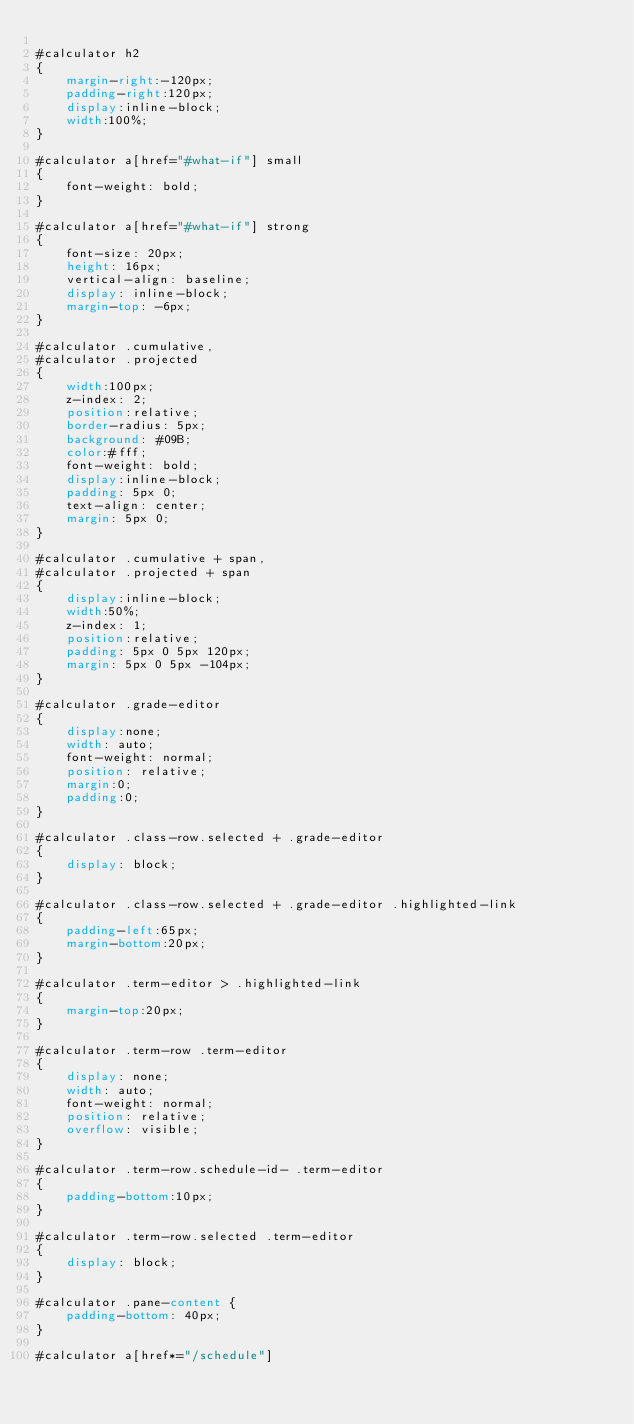Convert code to text. <code><loc_0><loc_0><loc_500><loc_500><_CSS_>
#calculator h2
{
    margin-right:-120px;
    padding-right:120px;
    display:inline-block;
    width:100%;
}

#calculator a[href="#what-if"] small
{
    font-weight: bold;
}

#calculator a[href="#what-if"] strong
{
    font-size: 20px;
    height: 16px;
    vertical-align: baseline;
    display: inline-block;
    margin-top: -6px;
}

#calculator .cumulative,
#calculator .projected
{
    width:100px;
    z-index: 2;
    position:relative;
    border-radius: 5px;
    background: #09B;
    color:#fff;
    font-weight: bold;
    display:inline-block;
    padding: 5px 0;
    text-align: center;
    margin: 5px 0;
}

#calculator .cumulative + span,
#calculator .projected + span
{
    display:inline-block;
    width:50%;
    z-index: 1;
    position:relative;
    padding: 5px 0 5px 120px;
    margin: 5px 0 5px -104px;
}

#calculator .grade-editor
{
    display:none;
    width: auto;
    font-weight: normal;
    position: relative;
    margin:0;
    padding:0;
}

#calculator .class-row.selected + .grade-editor
{
    display: block;
}

#calculator .class-row.selected + .grade-editor .highlighted-link
{
    padding-left:65px;
    margin-bottom:20px;
}

#calculator .term-editor > .highlighted-link
{
    margin-top:20px;
}

#calculator .term-row .term-editor
{
    display: none;
    width: auto;
    font-weight: normal;
    position: relative;
    overflow: visible;
}

#calculator .term-row.schedule-id- .term-editor
{
    padding-bottom:10px;
}

#calculator .term-row.selected .term-editor
{
    display: block;
}

#calculator .pane-content {
    padding-bottom: 40px;
}

#calculator a[href*="/schedule"]</code> 